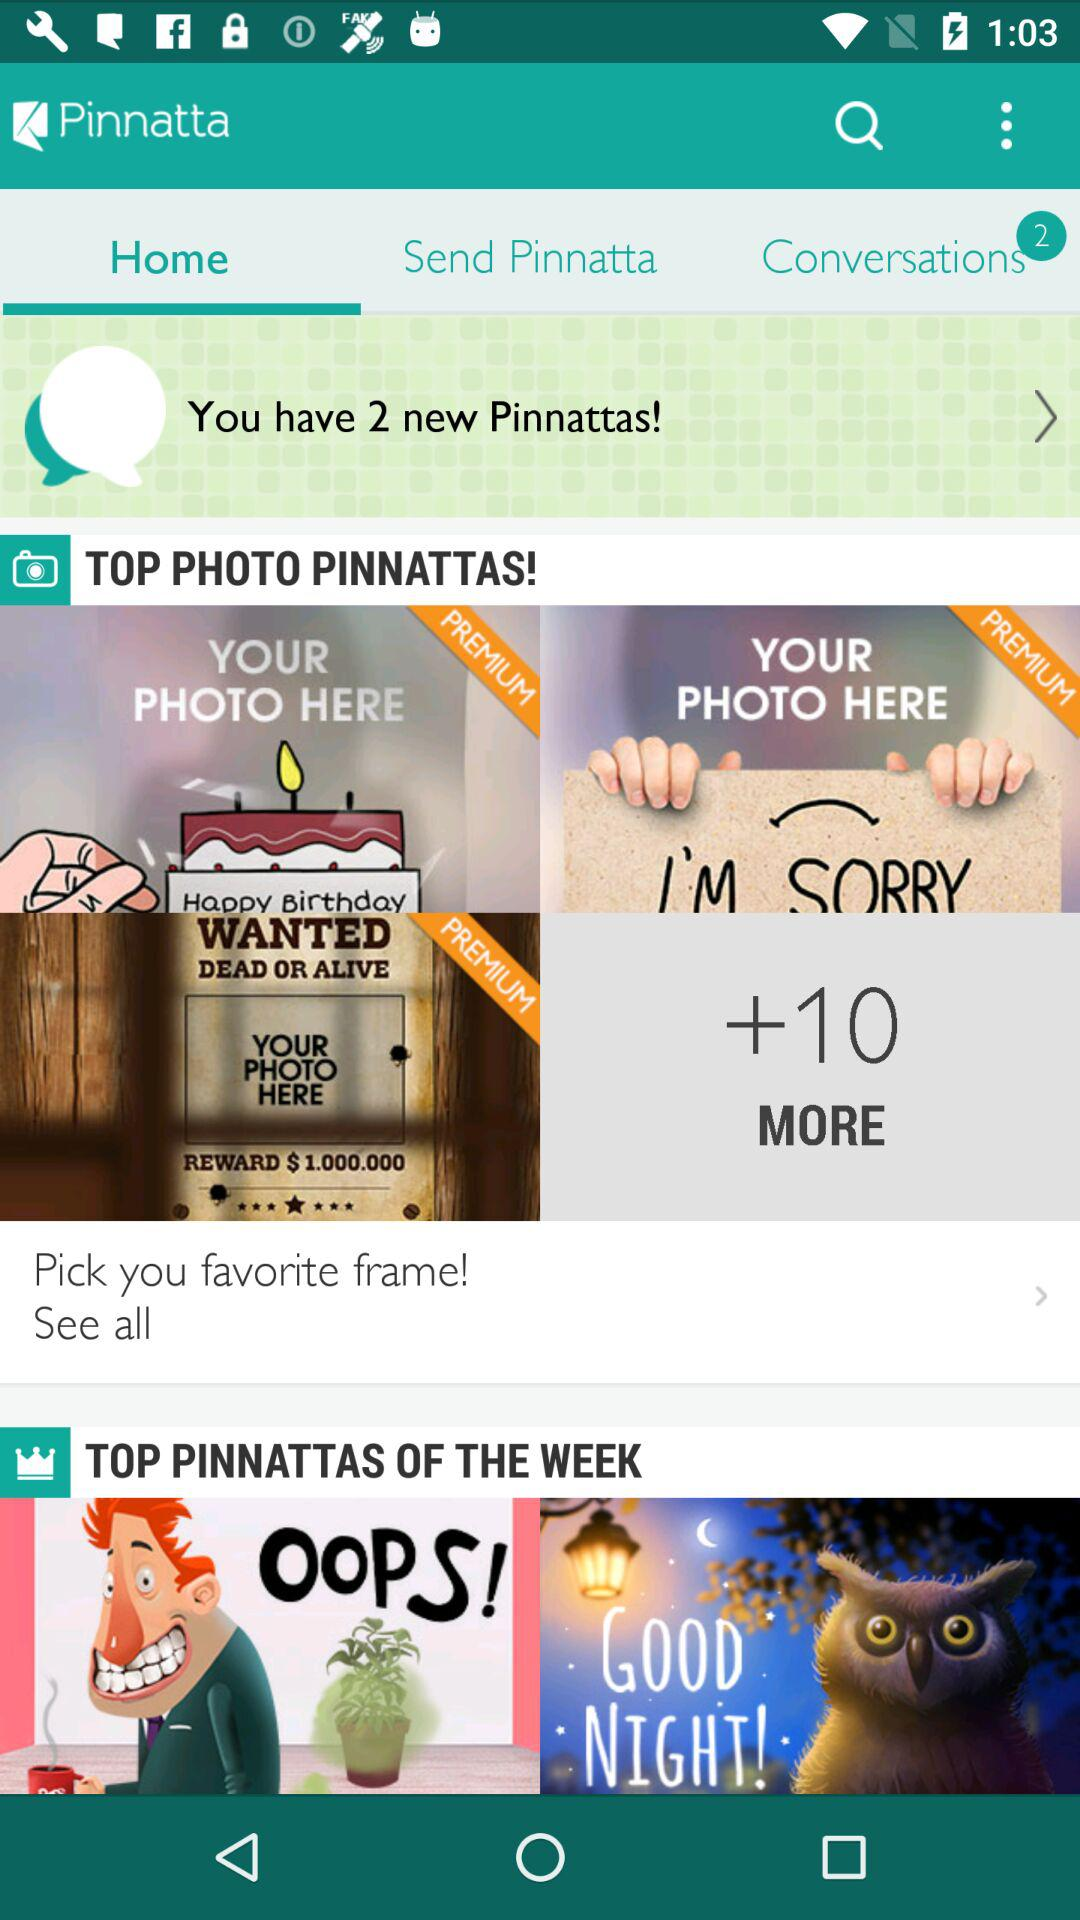Which tab is selected? The selected tab is "Home". 